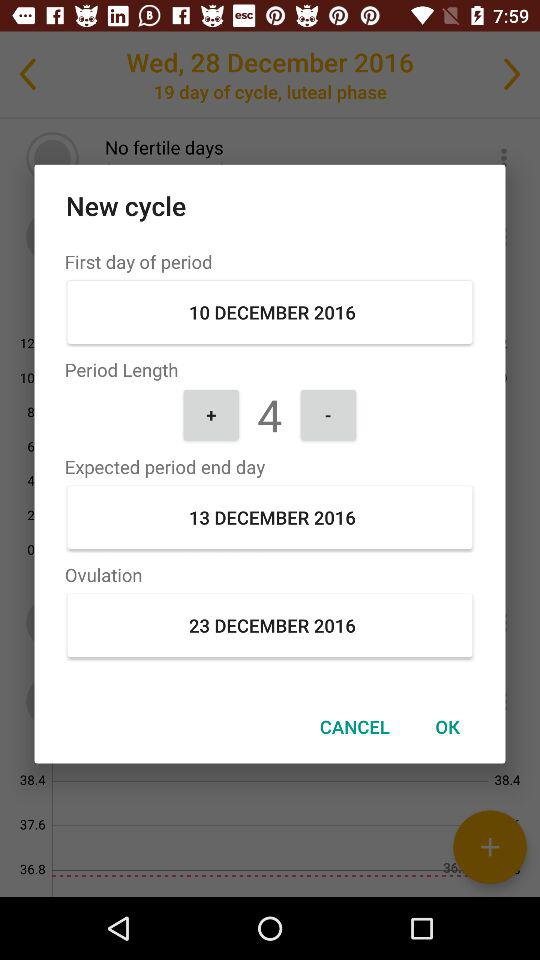What is the expected period end date? The expected period end date is December 13, 2016. 